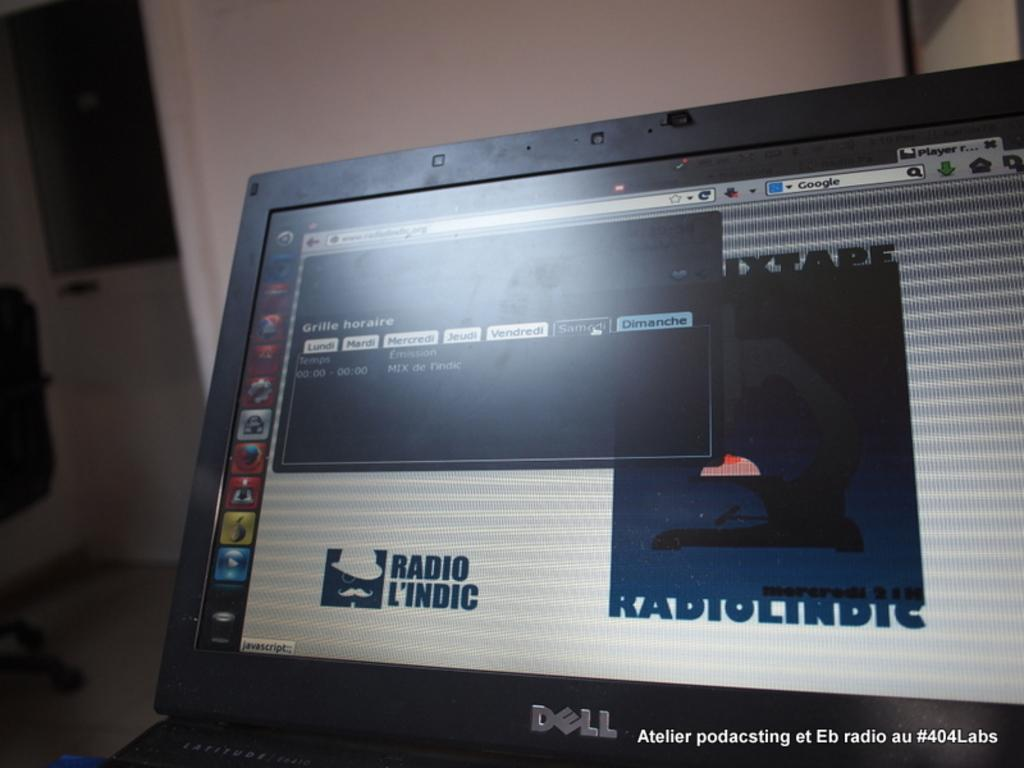<image>
Provide a brief description of the given image. Laptop monitor showing the words "RADIO L'INDIC" on it. 